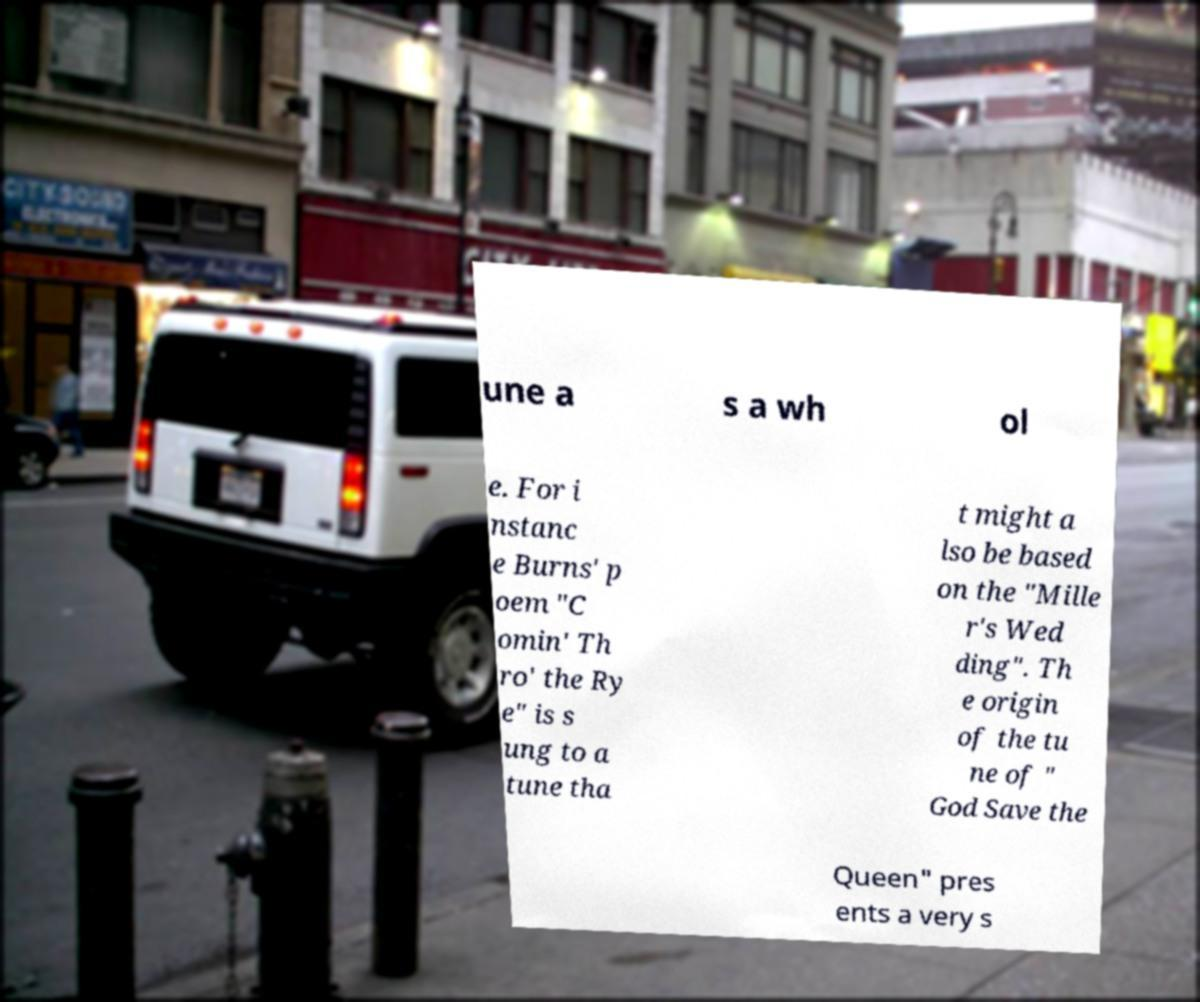Please identify and transcribe the text found in this image. une a s a wh ol e. For i nstanc e Burns' p oem "C omin' Th ro' the Ry e" is s ung to a tune tha t might a lso be based on the "Mille r's Wed ding". Th e origin of the tu ne of " God Save the Queen" pres ents a very s 